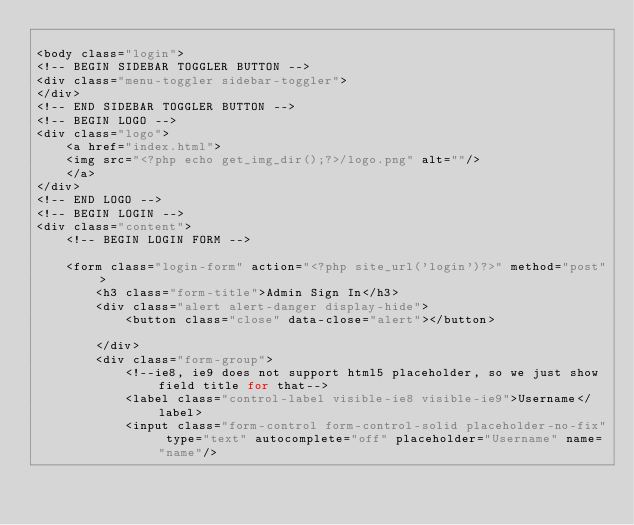<code> <loc_0><loc_0><loc_500><loc_500><_PHP_>
<body class="login">
<!-- BEGIN SIDEBAR TOGGLER BUTTON -->
<div class="menu-toggler sidebar-toggler">
</div>
<!-- END SIDEBAR TOGGLER BUTTON -->
<!-- BEGIN LOGO -->
<div class="logo">
	<a href="index.html">
	<img src="<?php echo get_img_dir();?>/logo.png" alt=""/>
	</a>
</div>
<!-- END LOGO -->
<!-- BEGIN LOGIN -->
<div class="content">
	<!-- BEGIN LOGIN FORM -->
	
	<form class="login-form" action="<?php site_url('login')?>" method="post">
		<h3 class="form-title">Admin Sign In</h3>
		<div class="alert alert-danger display-hide">
			<button class="close" data-close="alert"></button>
			
		</div>
		<div class="form-group">
			<!--ie8, ie9 does not support html5 placeholder, so we just show field title for that-->
			<label class="control-label visible-ie8 visible-ie9">Username</label>
			<input class="form-control form-control-solid placeholder-no-fix" type="text" autocomplete="off" placeholder="Username" name="name"/></code> 